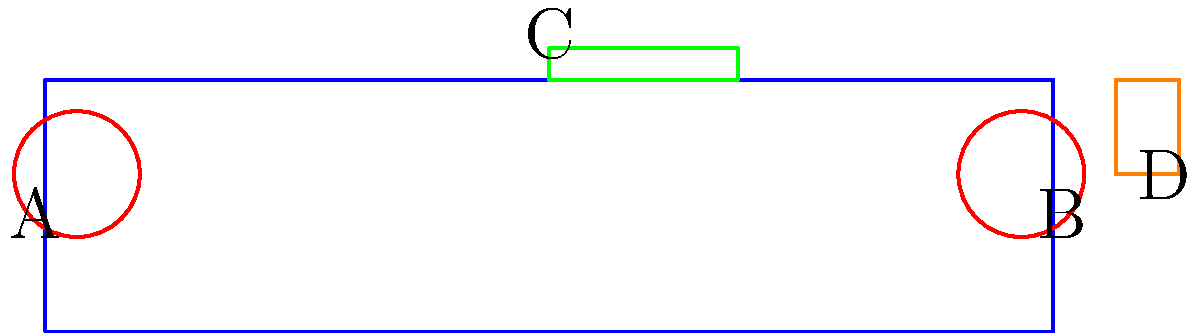As a sales manager, you're presenting a new aircraft design to potential clients. The diagram shows a simplified top view of an aircraft with four main components labeled A, B, C, and D. Which arrangement of these components would likely result in the most aerodynamically efficient design? To determine the most aerodynamically efficient arrangement, let's analyze each component:

1. Components A and B: These are circular shapes, likely representing engines. In modern aircraft design, engines are typically placed symmetrically on either side of the fuselage for balance and thrust distribution.

2. Component C: This is a long, thin shape spanning the width of the aircraft, representing wings. Wings are crucial for generating lift and are most effective when placed near the center of the aircraft's body.

3. Component D: This smaller vertical shape at the rear of the aircraft represents the tail. The tail provides stability and control, and is most effective when placed at the rear of the aircraft.

The current arrangement in the diagram is already optimal for aerodynamic efficiency:

- Engines (A and B) are symmetrically placed on either side of the fuselage.
- Wings (C) are centrally located, spanning the width of the aircraft.
- The tail (D) is positioned at the rear of the aircraft.

This configuration allows for:
- Balanced thrust from the engines
- Maximum lift generation from the wings
- Proper stability and control from the tail

Any significant deviation from this arrangement would likely result in reduced aerodynamic efficiency or stability issues.
Answer: The current arrangement (A, B, C, D as shown) is optimal. 